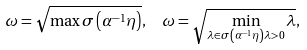<formula> <loc_0><loc_0><loc_500><loc_500>\omega = \sqrt { \max \sigma \left ( \alpha ^ { - 1 } \eta \right ) } , \text {\ \ } \omega = \sqrt { \min _ { \lambda \in \sigma \left ( \alpha ^ { - 1 } \eta \right ) \lambda > 0 } \lambda } ,</formula> 